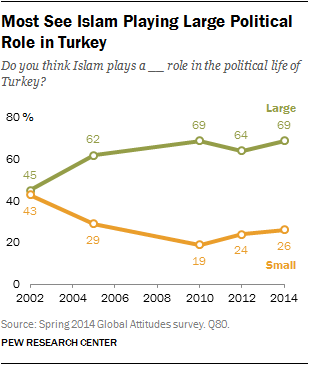Mention a couple of crucial points in this snapshot. According to the survey, 69% of respondents believe that Islam plays a large role in the political life of Turkey. In the year 2002, the difference between the value of Large and Small was significant. 